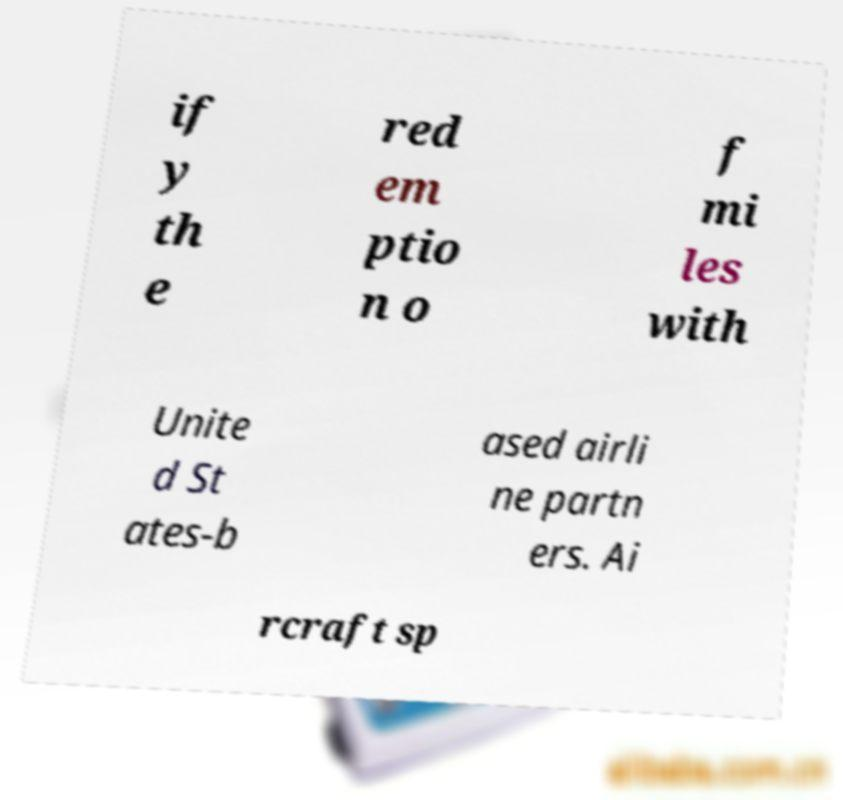I need the written content from this picture converted into text. Can you do that? if y th e red em ptio n o f mi les with Unite d St ates-b ased airli ne partn ers. Ai rcraft sp 